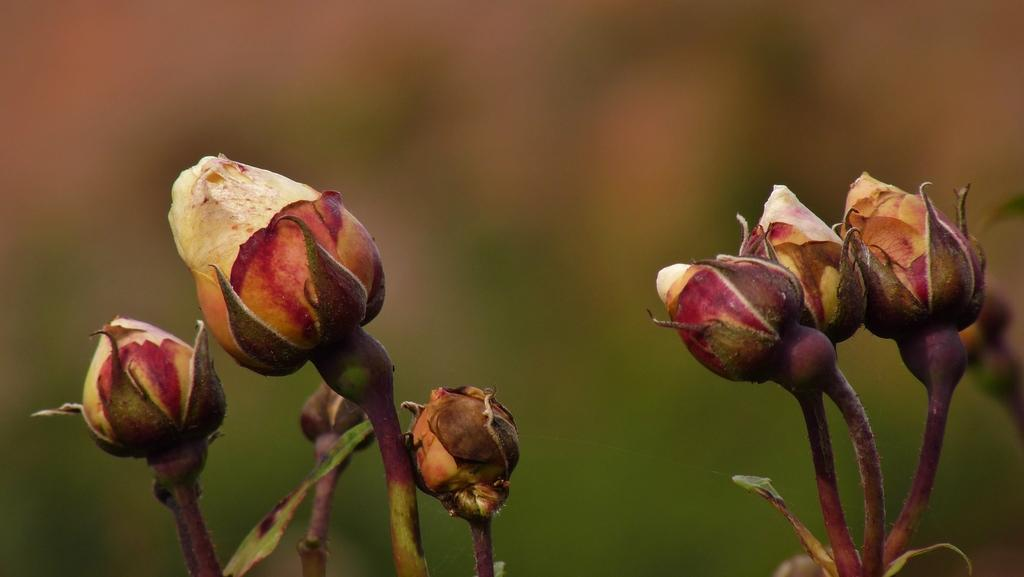What is the main subject of the image? The main subject of the image is flowers buds. Where are the flowers buds located in the image? The flowers buds are in the center of the image. How many people are swimming in the group of flowers buds? There are no people or swimming activity present in the image, as it features only flowers buds. 